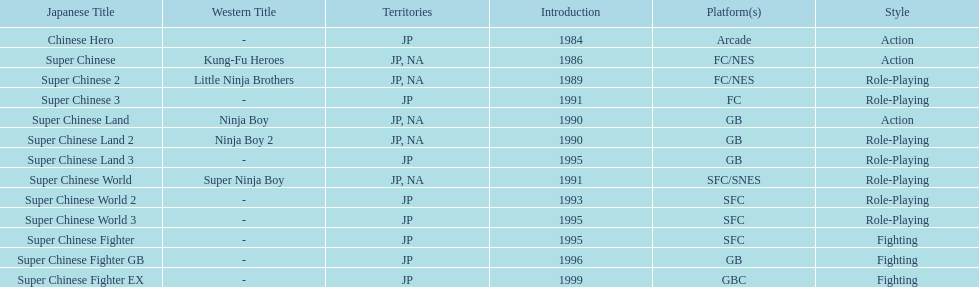What japanese titles were released in the north american (na) region? Super Chinese, Super Chinese 2, Super Chinese Land, Super Chinese Land 2, Super Chinese World. Of those, which one was released most recently? Super Chinese World. 